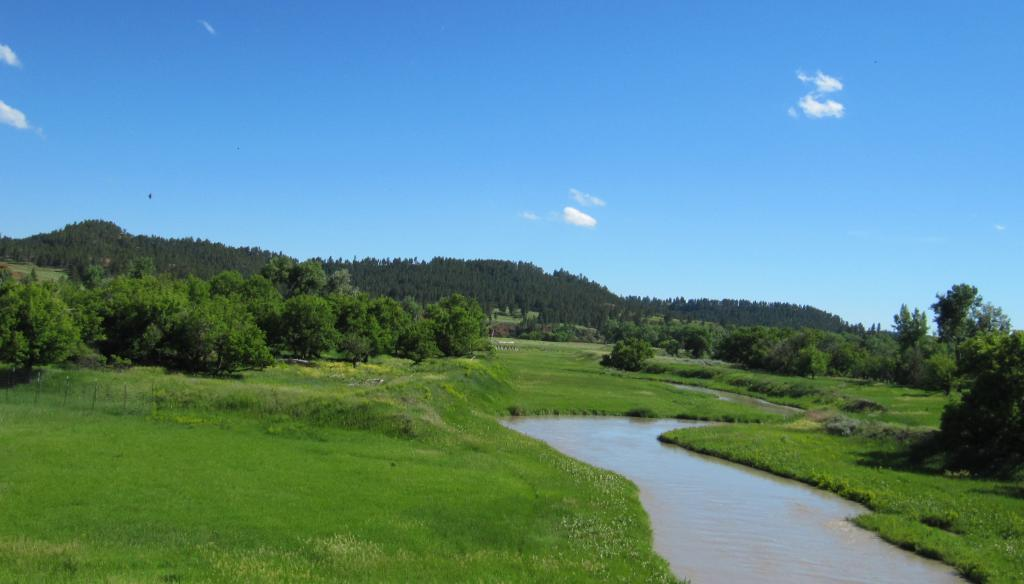What color is the sky in the image? The sky is blue in the image. What natural element can be seen in the image? There is water visible in the image. What type of vegetation is present in the image? There is grass and trees in the image. Are there any other weather phenomena visible in the sky? Yes, there are clouds in the sky. Can you see a wren perched on the tree in the image? There is no wren present in the image. Is there a balloon floating in the sky in the image? There is no balloon visible in the sky in the image. 